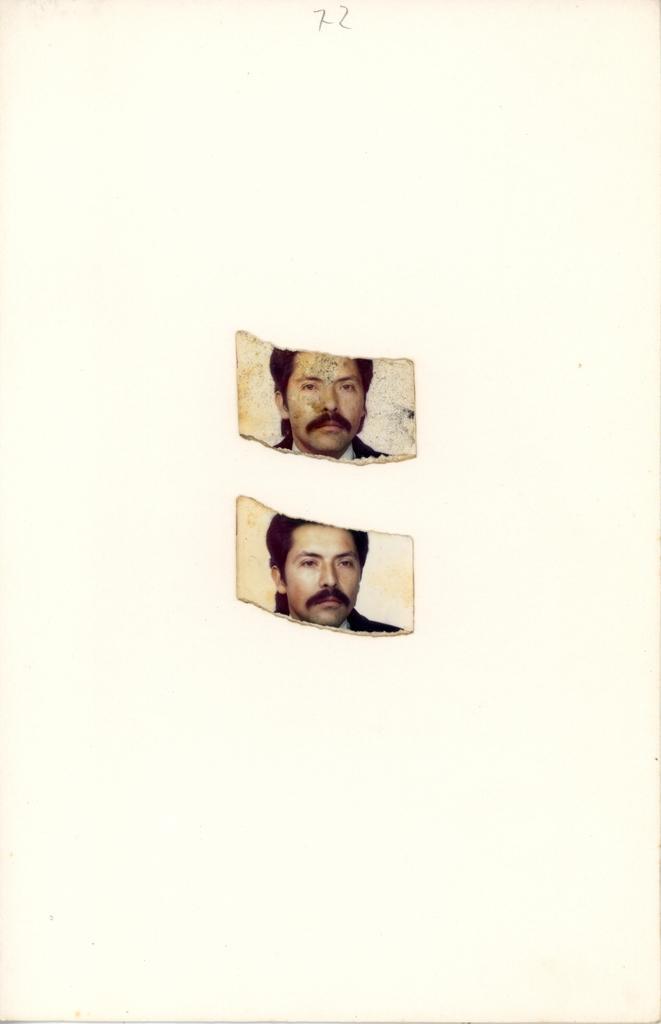Could you give a brief overview of what you see in this image? In this image there are two photos of the person, the background of the photos is white. 